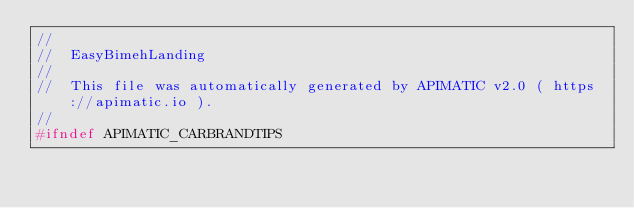Convert code to text. <code><loc_0><loc_0><loc_500><loc_500><_C_>//
//  EasyBimehLanding
//
//  This file was automatically generated by APIMATIC v2.0 ( https://apimatic.io ).
//
#ifndef APIMATIC_CARBRANDTIPS</code> 